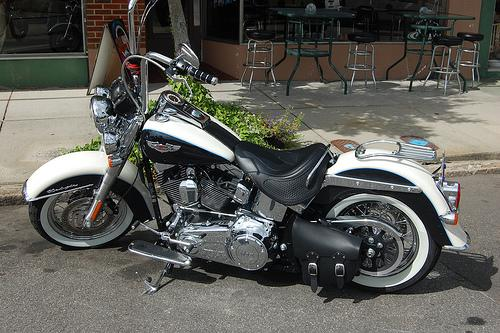What furniture can be seen in the image? Green metal patio table, outdoor dining table, two bar stools with black seats, right bistro table near the wall, and left bistro table and stools. What kind of sentiment does this image evoke? The image evokes a feeling of leisure and relaxation with a focus on a stylish motorcycle. Identify the primary object in the image along with its defining characteristics. A white and black Harley-Davidson motorcycle is the main object, characterized by its chrome engine, logo, and saddlebags. What kind of emblem can be found on the motorcycle? A metal emblem with the Harley-Davidson logo can be found on the motorcycle. Can you tell me the items in the image that are related to shadows and reflections? Shadow of a motorcycle, the shadow of a tree, shadow of tree canopy, and reflection of the motorcycle. How many bar stools are there in the image, and what color are their seats? There are two bar stools in the image, and their seats are black. Enumerate some noticeable features on the motorcycle. Kickstand, saddlebags, rear fender, handlebars, windshield, white front fender, chrome engine, and Harley-Davidson logo. What are the two main colors of the motorcycle in the image? The two main colors of the motorcycle are white and black. Provide a brief description of the scene based on the objects and their interactions in the image. A white and black Harley-Davidson motorcycle is parked near a green metal patio table and barstools, with shadows and reflections on the surroundings indicating a sunny day. Describe the quality of the image in terms of object clarity. The image has clear and well-defined objects, with different features and details of the motorcycle and surrounding elements visible. 